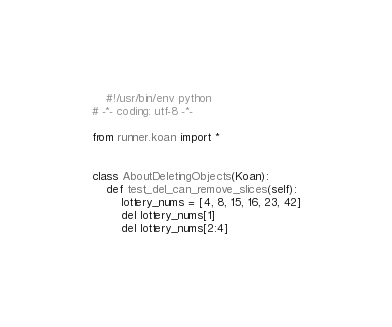<code> <loc_0><loc_0><loc_500><loc_500><_Python_>    #!/usr/bin/env python
# -*- coding: utf-8 -*-

from runner.koan import *


class AboutDeletingObjects(Koan):
    def test_del_can_remove_slices(self):
        lottery_nums = [4, 8, 15, 16, 23, 42]
        del lottery_nums[1]
        del lottery_nums[2:4]
</code> 